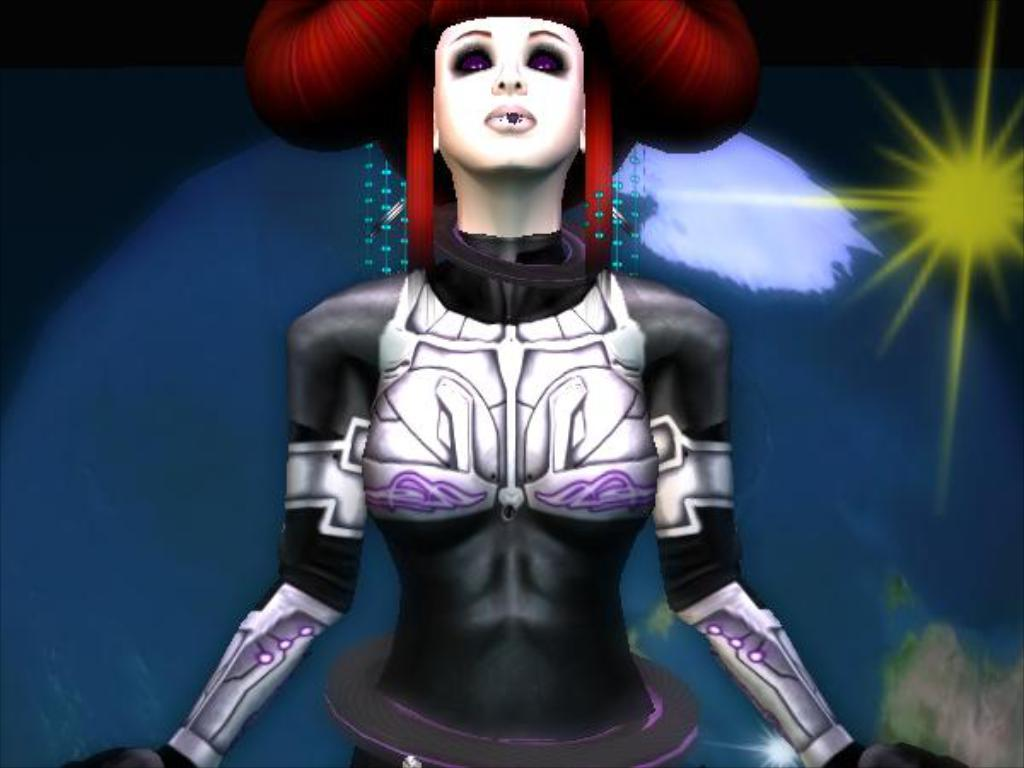What type of image is being described? The image is animated. Can you describe the woman in the image? There is a woman standing in the image. What can be seen in the background of the image? There is a globe and the sun visible in the background of the image. What type of neck accessory is the woman wearing in the image? There is no information about the woman's neck accessory in the image. Can you describe the seashore visible in the image? There is no seashore present in the image; it features a woman standing in front of a globe and the sun. 